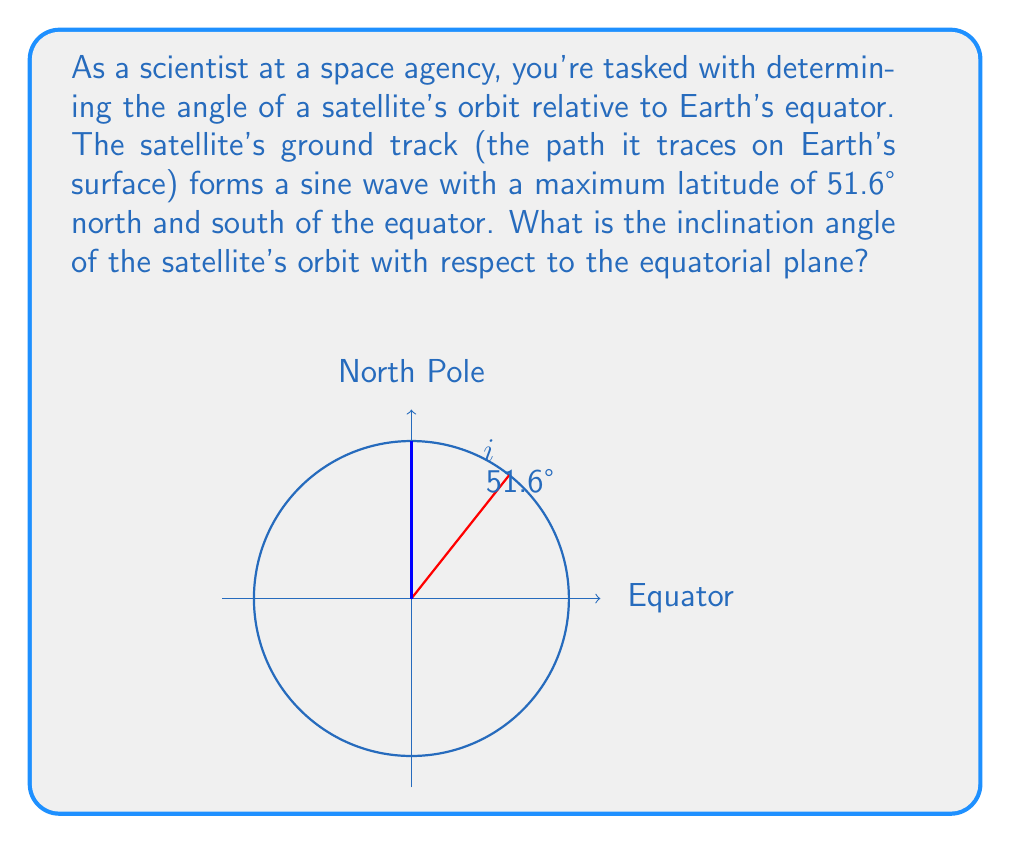Could you help me with this problem? To solve this problem, we need to understand the relationship between a satellite's orbital inclination and its ground track.

1) The inclination of a satellite's orbit is defined as the angle between the orbital plane and the Earth's equatorial plane.

2) For a circular orbit (which we'll assume for simplicity), the maximum latitude reached by the satellite is equal to its orbital inclination.

3) This is because the orbital plane intersects the Earth's surface at its maximum northward and southward points at an angle equal to the inclination.

4) In this case, we're given that the maximum latitude of the ground track is 51.6° north and south of the equator.

5) Therefore, the inclination angle of the satellite's orbit is also 51.6°.

It's worth noting that this simple relationship between maximum latitude and inclination holds true for circular orbits. For elliptical orbits, the relationship becomes more complex, and additional information about the orbit's shape would be needed to determine the inclination precisely.

In the space industry, an inclination of 51.6° is significant as it's the inclination of the International Space Station's orbit. This inclination was chosen as a compromise between the orbital preferences of the various international partners and the latitude of the main launch site in Kazakhstan.
Answer: The inclination angle of the satellite's orbit with respect to the equatorial plane is 51.6°. 